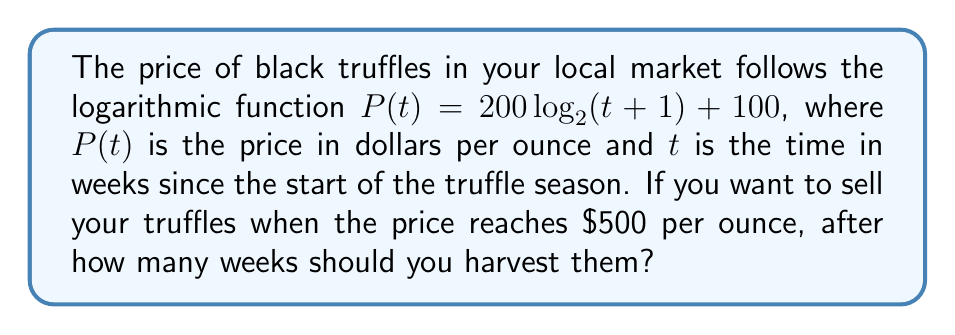Show me your answer to this math problem. Let's approach this step-by-step:

1) We need to solve the equation:
   $500 = 200 \log_2(t+1) + 100$

2) Subtract 100 from both sides:
   $400 = 200 \log_2(t+1)$

3) Divide both sides by 200:
   $2 = \log_2(t+1)$

4) Now, we need to apply the inverse function of $\log_2$, which is $2^x$:
   $2^2 = t+1$

5) Simplify:
   $4 = t+1$

6) Subtract 1 from both sides:
   $3 = t$

Therefore, you should harvest your truffles after 3 weeks when the price reaches $500 per ounce.
Answer: 3 weeks 